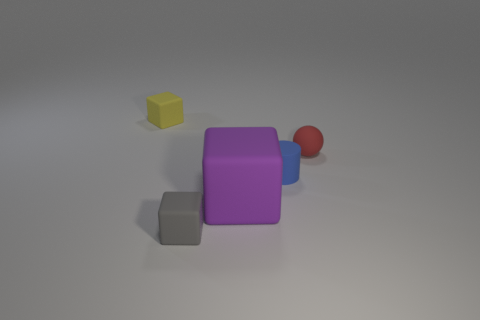Is the number of small cylinders greater than the number of tiny things?
Your answer should be compact. No. How many matte objects are small gray objects or yellow objects?
Give a very brief answer. 2. What color is the tiny cube behind the tiny matte cube that is in front of the tiny yellow matte block?
Your answer should be compact. Yellow. How many large objects are either blue rubber blocks or yellow things?
Keep it short and to the point. 0. How many red spheres are made of the same material as the small blue thing?
Offer a terse response. 1. There is a object that is on the right side of the small blue rubber object; what is its size?
Offer a terse response. Small. There is a tiny blue thing behind the small object in front of the big purple cube; what is its shape?
Make the answer very short. Cylinder. There is a small matte cube that is in front of the yellow rubber block behind the rubber sphere; how many small rubber things are on the right side of it?
Offer a terse response. 2. Is the number of small yellow matte blocks that are in front of the gray object less than the number of blue cylinders?
Give a very brief answer. Yes. Are there any other things that have the same shape as the tiny blue matte object?
Make the answer very short. No. 